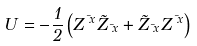<formula> <loc_0><loc_0><loc_500><loc_500>U = - \frac { 1 } { 2 } \left ( Z ^ { \mu x } \tilde { Z } _ { \mu x } + \tilde { Z } _ { \mu x } Z ^ { \mu x } \right )</formula> 